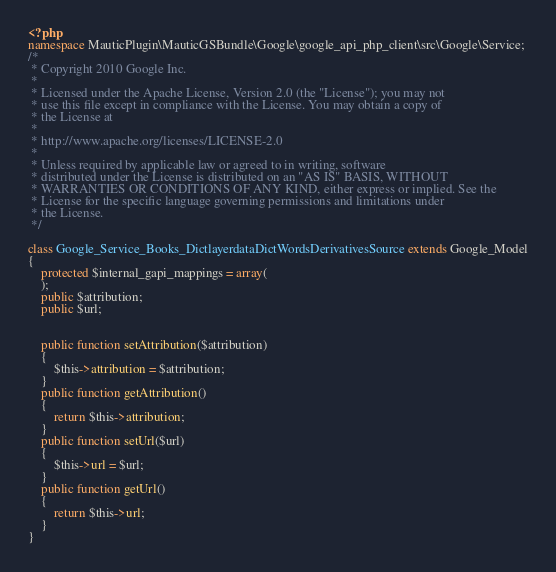Convert code to text. <code><loc_0><loc_0><loc_500><loc_500><_PHP_><?php
namespace MauticPlugin\MauticGSBundle\Google\google_api_php_client\src\Google\Service;
/*
 * Copyright 2010 Google Inc.
 *
 * Licensed under the Apache License, Version 2.0 (the "License"); you may not
 * use this file except in compliance with the License. You may obtain a copy of
 * the License at
 *
 * http://www.apache.org/licenses/LICENSE-2.0
 *
 * Unless required by applicable law or agreed to in writing, software
 * distributed under the License is distributed on an "AS IS" BASIS, WITHOUT
 * WARRANTIES OR CONDITIONS OF ANY KIND, either express or implied. See the
 * License for the specific language governing permissions and limitations under
 * the License.
 */

class Google_Service_Books_DictlayerdataDictWordsDerivativesSource extends Google_Model
{
    protected $internal_gapi_mappings = array(
    );
    public $attribution;
    public $url;


    public function setAttribution($attribution)
    {
        $this->attribution = $attribution;
    }
    public function getAttribution()
    {
        return $this->attribution;
    }
    public function setUrl($url)
    {
        $this->url = $url;
    }
    public function getUrl()
    {
        return $this->url;
    }
}
</code> 